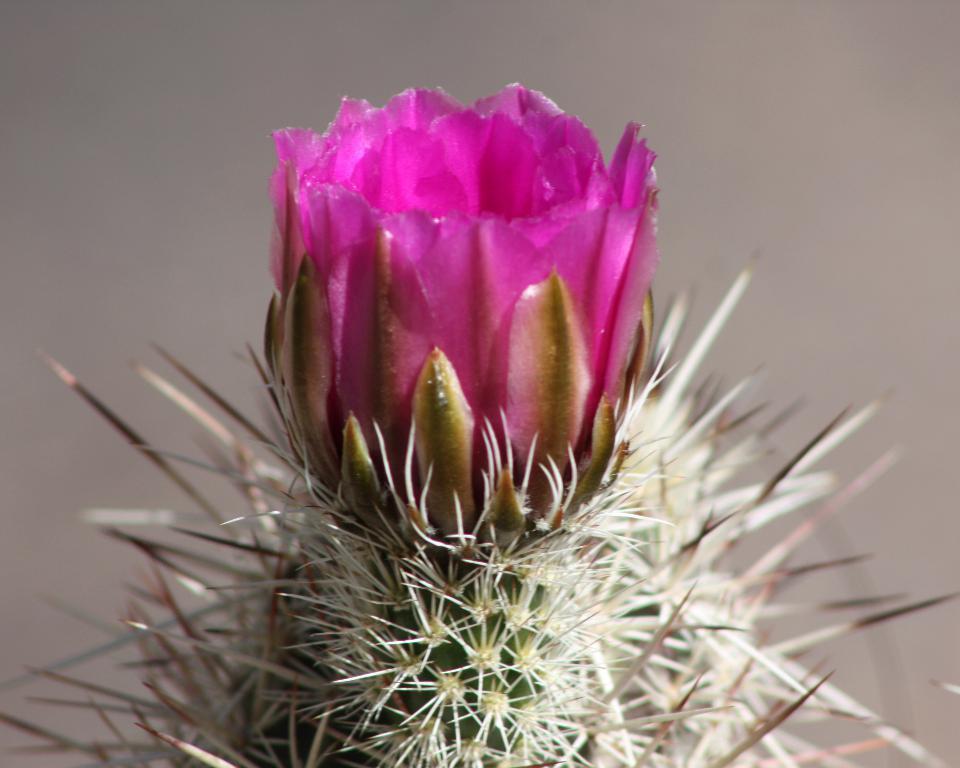Could you give a brief overview of what you see in this image? In the image we can see a cactus and this is a cactus flower. 